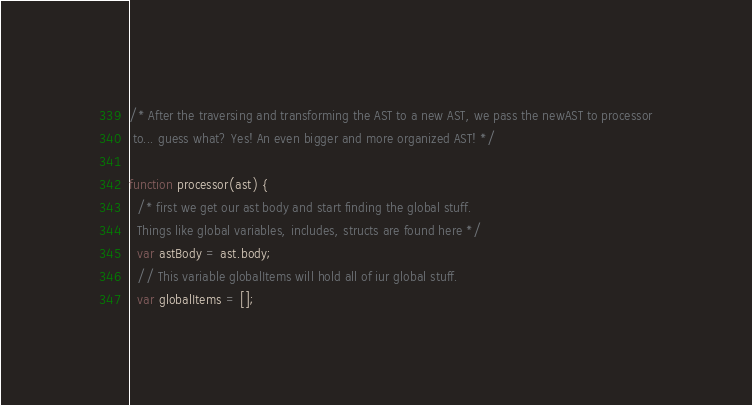<code> <loc_0><loc_0><loc_500><loc_500><_JavaScript_>/* After the traversing and transforming the AST to a new AST, we pass the newAST to processor
 to... guess what? Yes! An even bigger and more organized AST! */

function processor(ast) {
  /* first we get our ast body and start finding the global stuff.
  Things like global variables, includes, structs are found here */
  var astBody = ast.body;
  // This variable globalItems will hold all of iur global stuff.
  var globalItems = [];</code> 